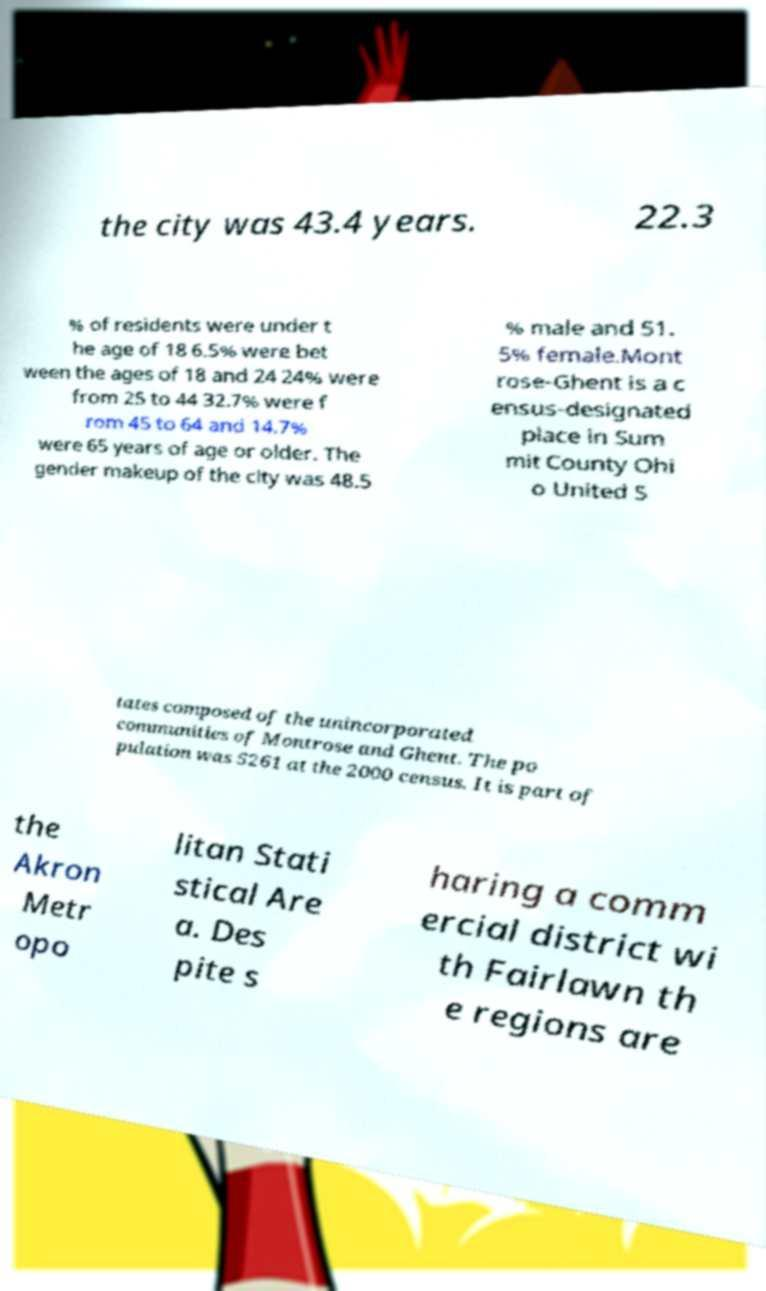Please read and relay the text visible in this image. What does it say? the city was 43.4 years. 22.3 % of residents were under t he age of 18 6.5% were bet ween the ages of 18 and 24 24% were from 25 to 44 32.7% were f rom 45 to 64 and 14.7% were 65 years of age or older. The gender makeup of the city was 48.5 % male and 51. 5% female.Mont rose-Ghent is a c ensus-designated place in Sum mit County Ohi o United S tates composed of the unincorporated communities of Montrose and Ghent. The po pulation was 5261 at the 2000 census. It is part of the Akron Metr opo litan Stati stical Are a. Des pite s haring a comm ercial district wi th Fairlawn th e regions are 